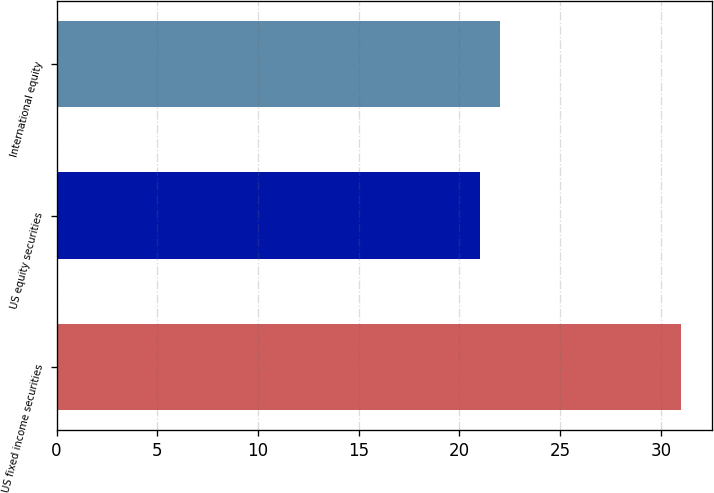Convert chart to OTSL. <chart><loc_0><loc_0><loc_500><loc_500><bar_chart><fcel>US fixed income securities<fcel>US equity securities<fcel>International equity<nl><fcel>31<fcel>21<fcel>22<nl></chart> 